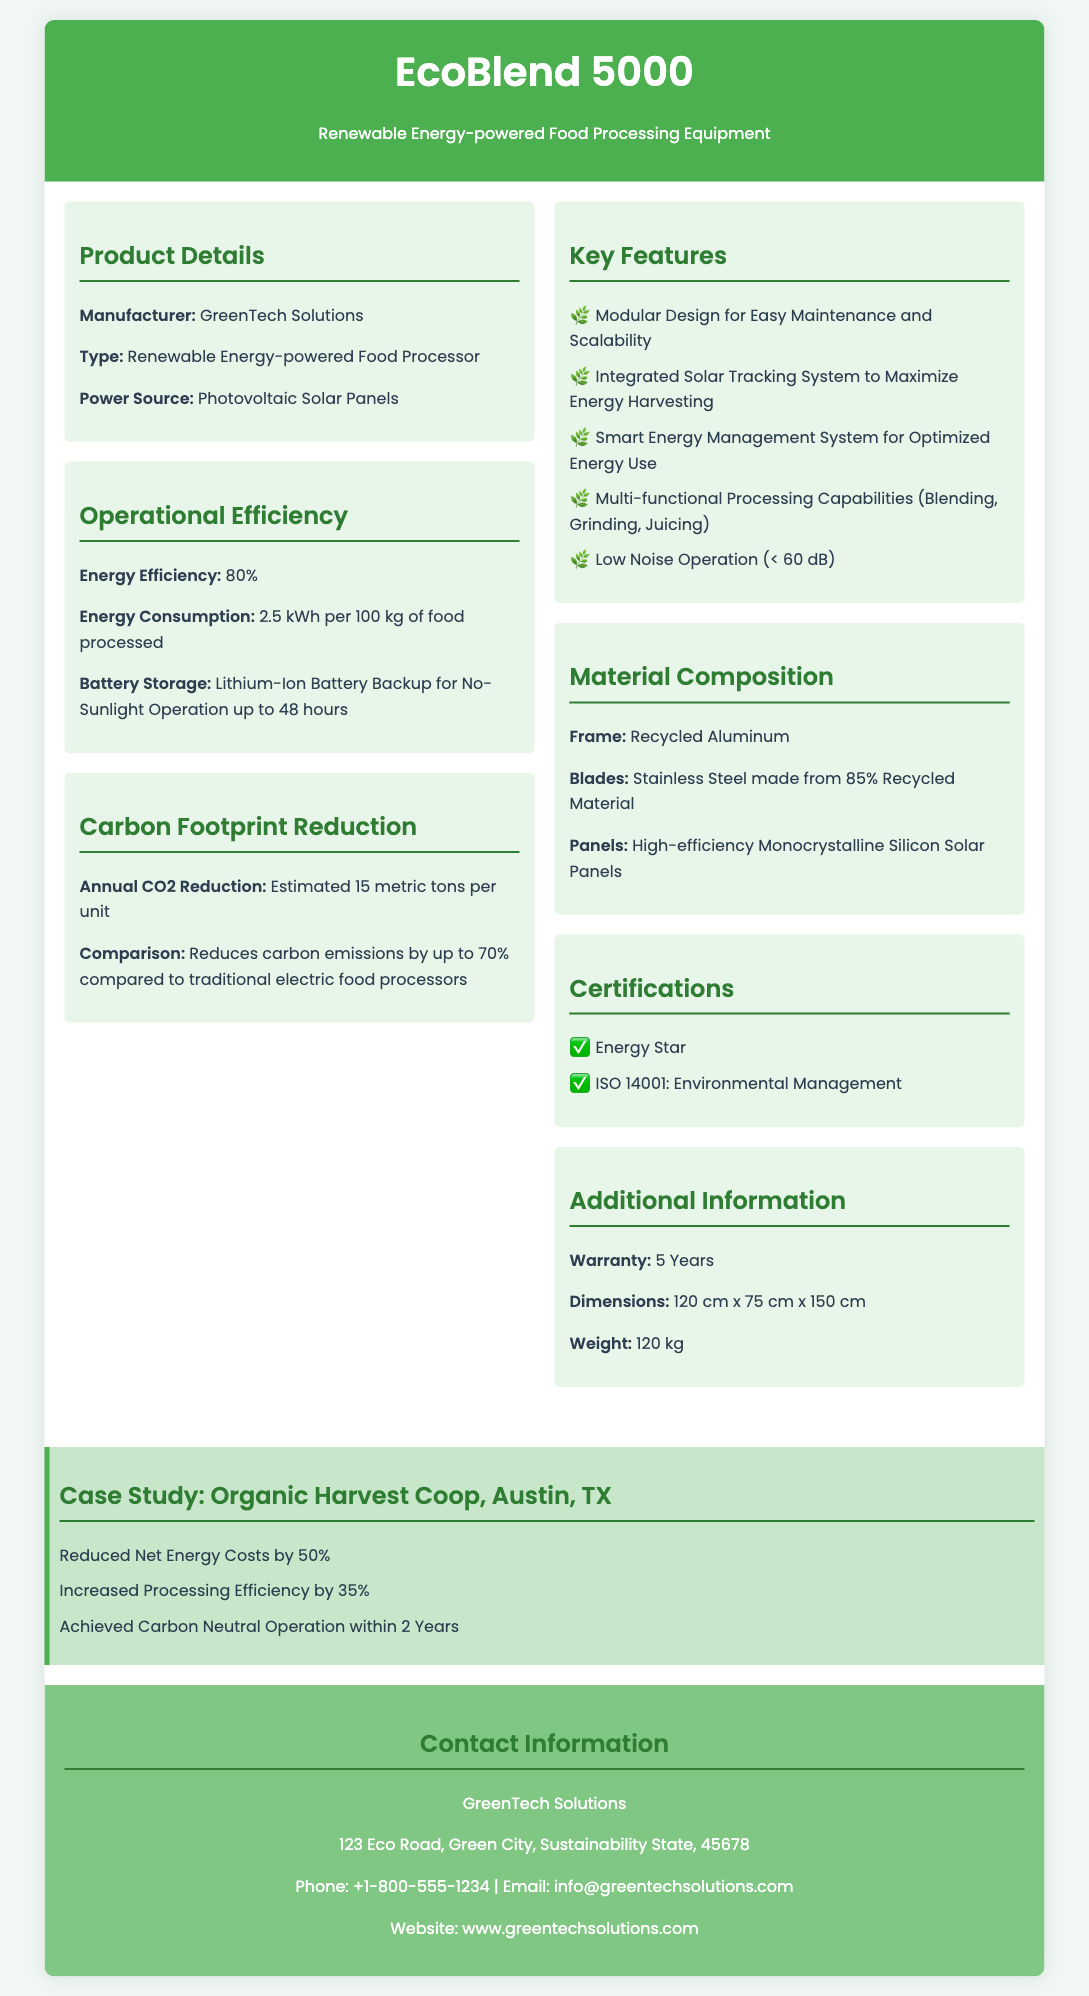what is the manufacturer's name? The manufacturer's name is listed in the product details section.
Answer: GreenTech Solutions what is the power source for the EcoBlend 5000? The power source is specified in the product details section.
Answer: Photovoltaic Solar Panels what is the energy efficiency percentage? The energy efficiency is provided in the operational efficiency section.
Answer: 80% how much energy does the EcoBlend 5000 consume per 100 kg of food processed? The energy consumption value can be found in the operational efficiency section.
Answer: 2.5 kWh how many metric tons of CO2 does the EcoBlend 5000 reduce annually? The annual CO2 reduction figure is mentioned in the carbon footprint reduction section.
Answer: 15 metric tons which material is used for the frame? The material composition section specifies the frame material.
Answer: Recycled Aluminum what is the noise level during operation? The noise level is mentioned in the key features section.
Answer: < 60 dB how many years is the warranty for the EcoBlend 5000? The warranty duration is listed in the additional information section.
Answer: 5 Years what is the dimension of the EcoBlend 5000? The dimensions are specified in the additional information section.
Answer: 120 cm x 75 cm x 150 cm which certification does the EcoBlend 5000 have? The certifications section lists the certifications obtained by the product.
Answer: Energy Star 